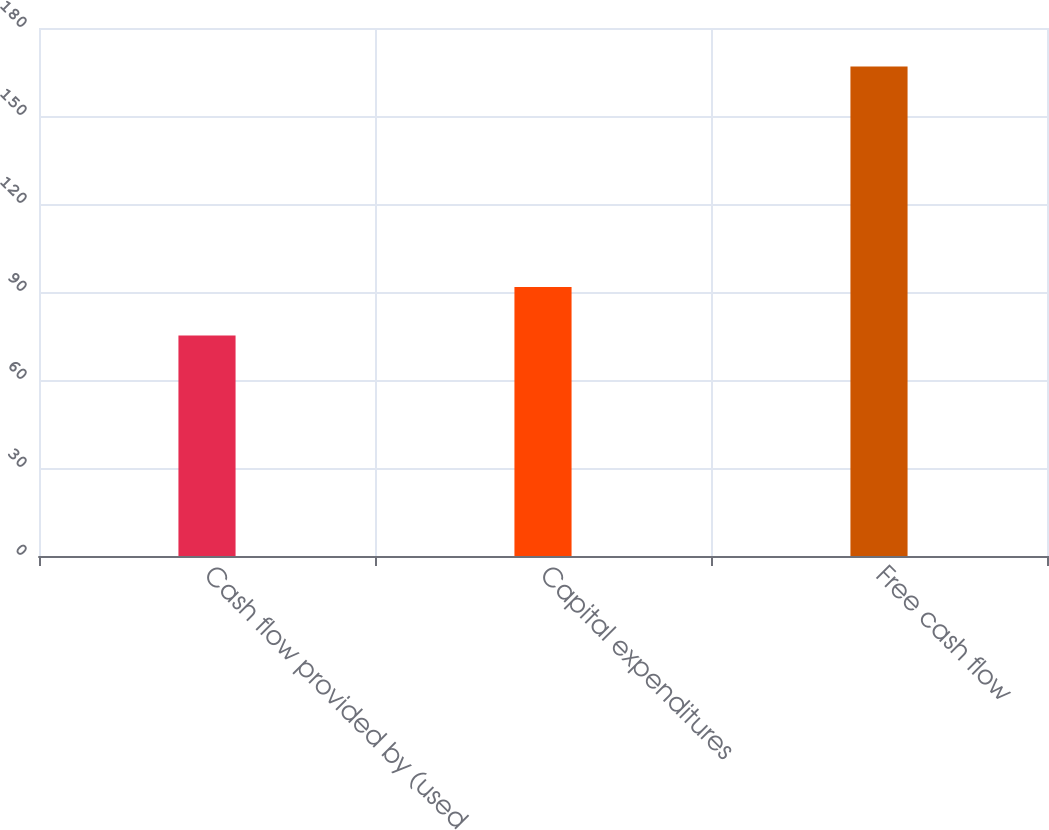Convert chart. <chart><loc_0><loc_0><loc_500><loc_500><bar_chart><fcel>Cash flow provided by (used<fcel>Capital expenditures<fcel>Free cash flow<nl><fcel>75.2<fcel>91.7<fcel>166.9<nl></chart> 